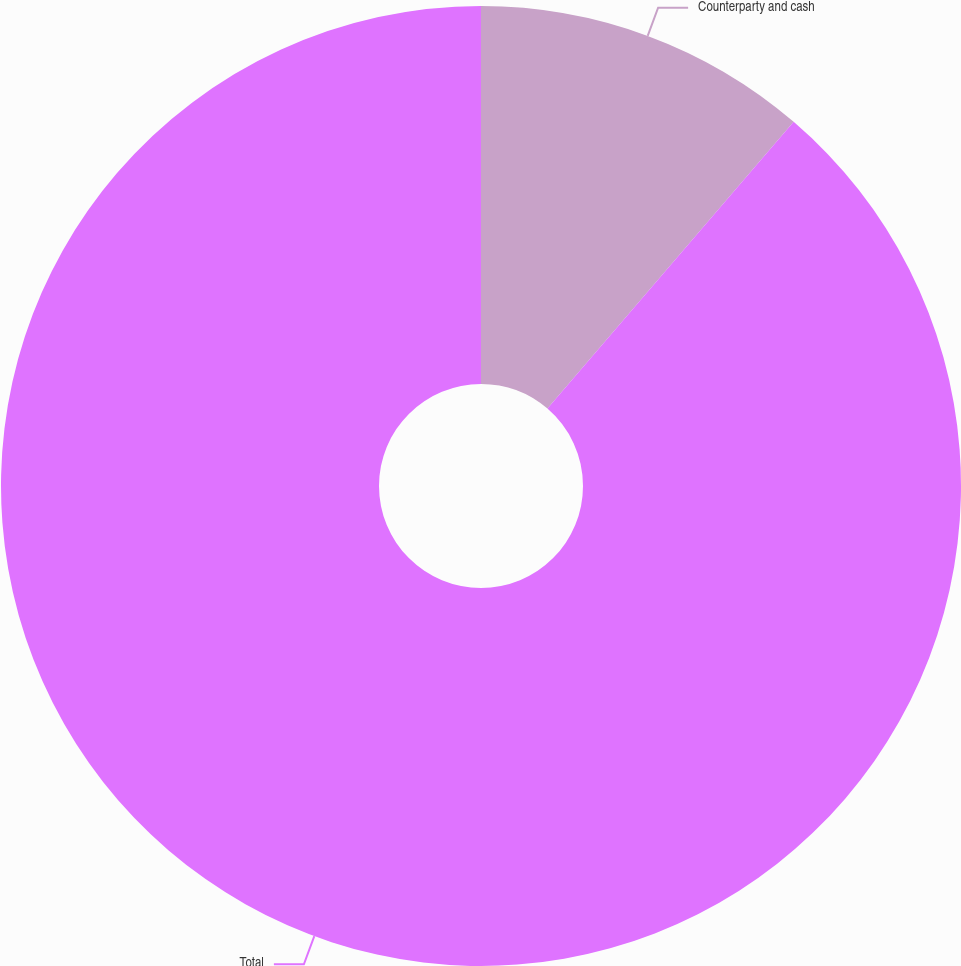<chart> <loc_0><loc_0><loc_500><loc_500><pie_chart><fcel>Counterparty and cash<fcel>Total<nl><fcel>11.29%<fcel>88.71%<nl></chart> 